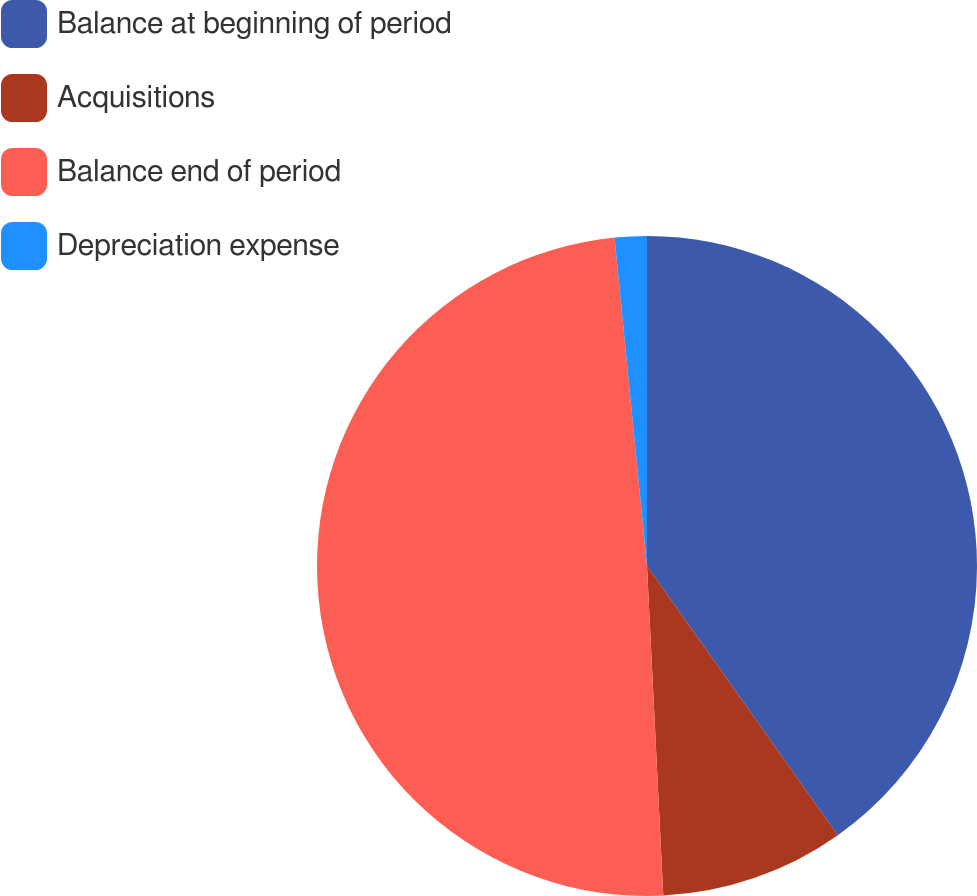Convert chart to OTSL. <chart><loc_0><loc_0><loc_500><loc_500><pie_chart><fcel>Balance at beginning of period<fcel>Acquisitions<fcel>Balance end of period<fcel>Depreciation expense<nl><fcel>40.19%<fcel>9.03%<fcel>49.22%<fcel>1.57%<nl></chart> 